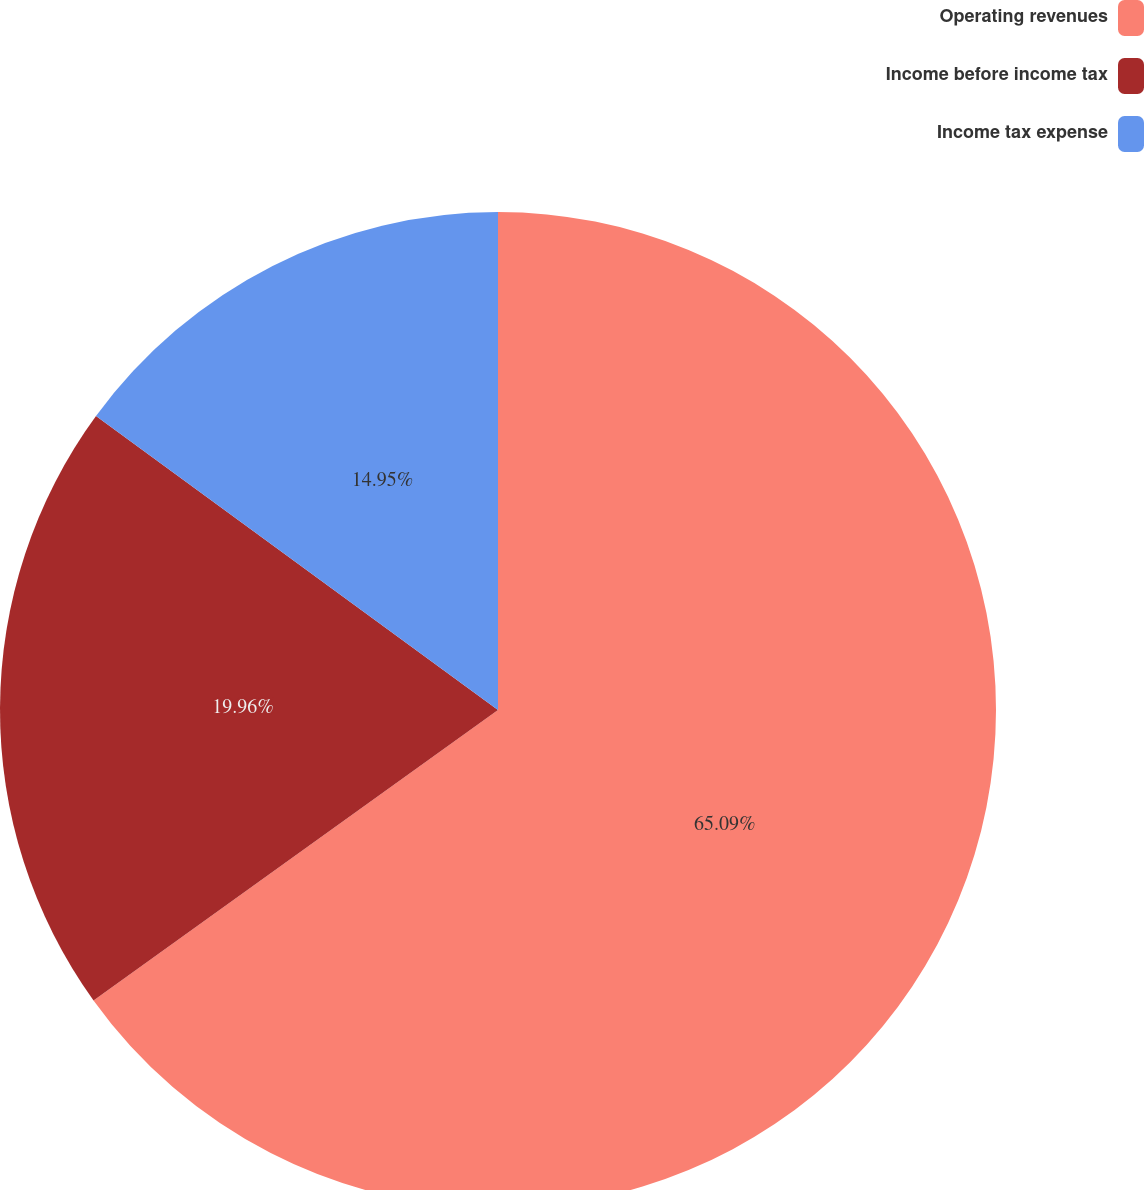Convert chart to OTSL. <chart><loc_0><loc_0><loc_500><loc_500><pie_chart><fcel>Operating revenues<fcel>Income before income tax<fcel>Income tax expense<nl><fcel>65.08%<fcel>19.96%<fcel>14.95%<nl></chart> 